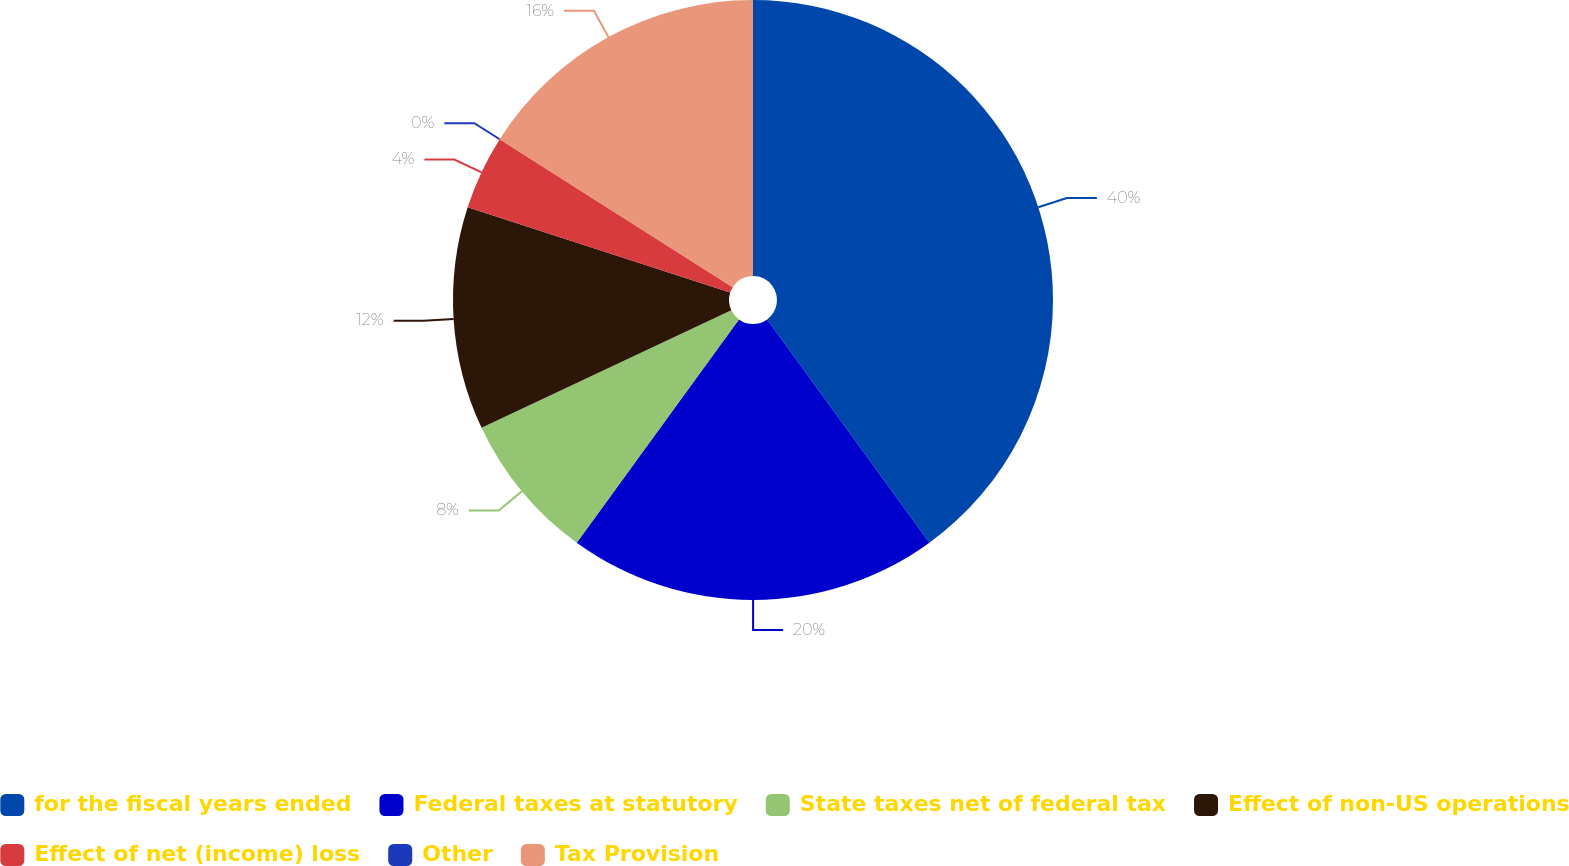<chart> <loc_0><loc_0><loc_500><loc_500><pie_chart><fcel>for the fiscal years ended<fcel>Federal taxes at statutory<fcel>State taxes net of federal tax<fcel>Effect of non-US operations<fcel>Effect of net (income) loss<fcel>Other<fcel>Tax Provision<nl><fcel>39.99%<fcel>20.0%<fcel>8.0%<fcel>12.0%<fcel>4.0%<fcel>0.0%<fcel>16.0%<nl></chart> 